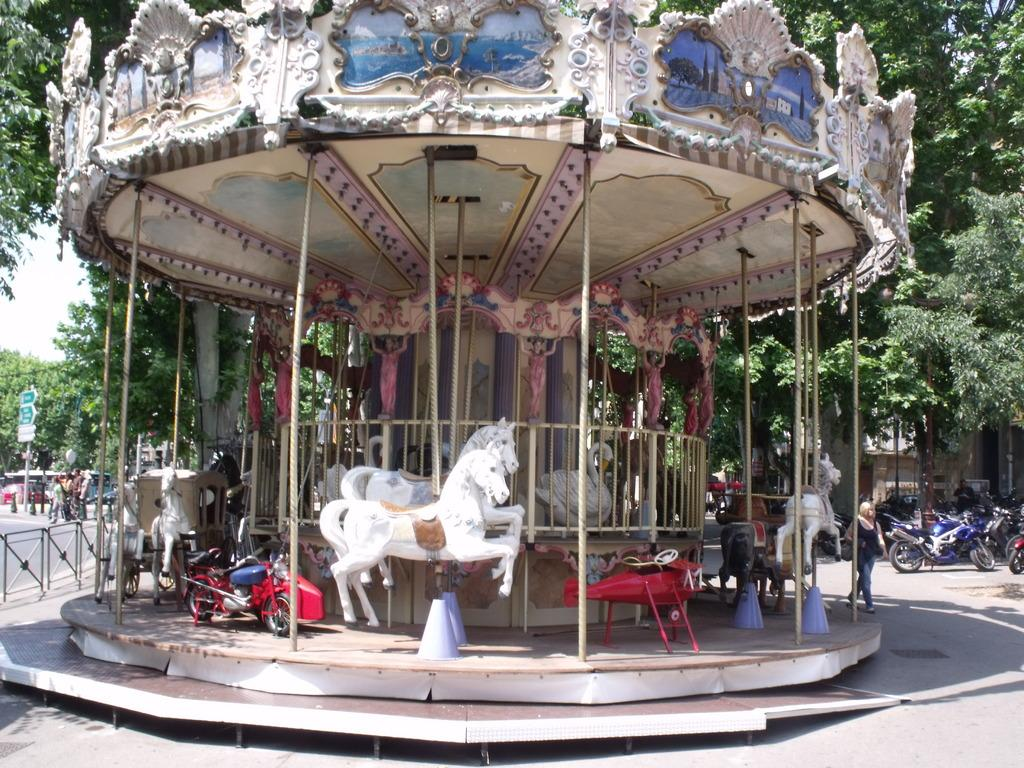What is the main subject in the middle of the picture? There is a carousel in the middle of the picture. What can be seen on the right side of the picture? There are bikes parked on the right side of the picture. Where are the bikes located? The bikes are in a parking lot. What can be seen in the background of the picture? There are trees visible in the background of the picture. How does the quiet cup of theory affect the carousel in the image? There is no mention of a quiet cup of theory in the image, so it cannot affect the carousel. 